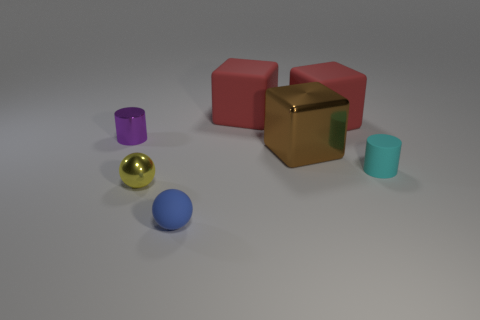Subtract all red rubber blocks. How many blocks are left? 1 Add 2 gray metal objects. How many objects exist? 9 Subtract all cylinders. How many objects are left? 5 Subtract 2 cylinders. How many cylinders are left? 0 Subtract all brown cylinders. Subtract all red blocks. How many cylinders are left? 2 Subtract all purple blocks. How many purple cylinders are left? 1 Subtract all blue objects. Subtract all large yellow rubber things. How many objects are left? 6 Add 2 cylinders. How many cylinders are left? 4 Add 3 matte balls. How many matte balls exist? 4 Subtract all brown cubes. How many cubes are left? 2 